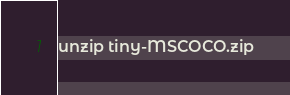<code> <loc_0><loc_0><loc_500><loc_500><_Bash_>unzip tiny-MSCOCO.zip</code> 